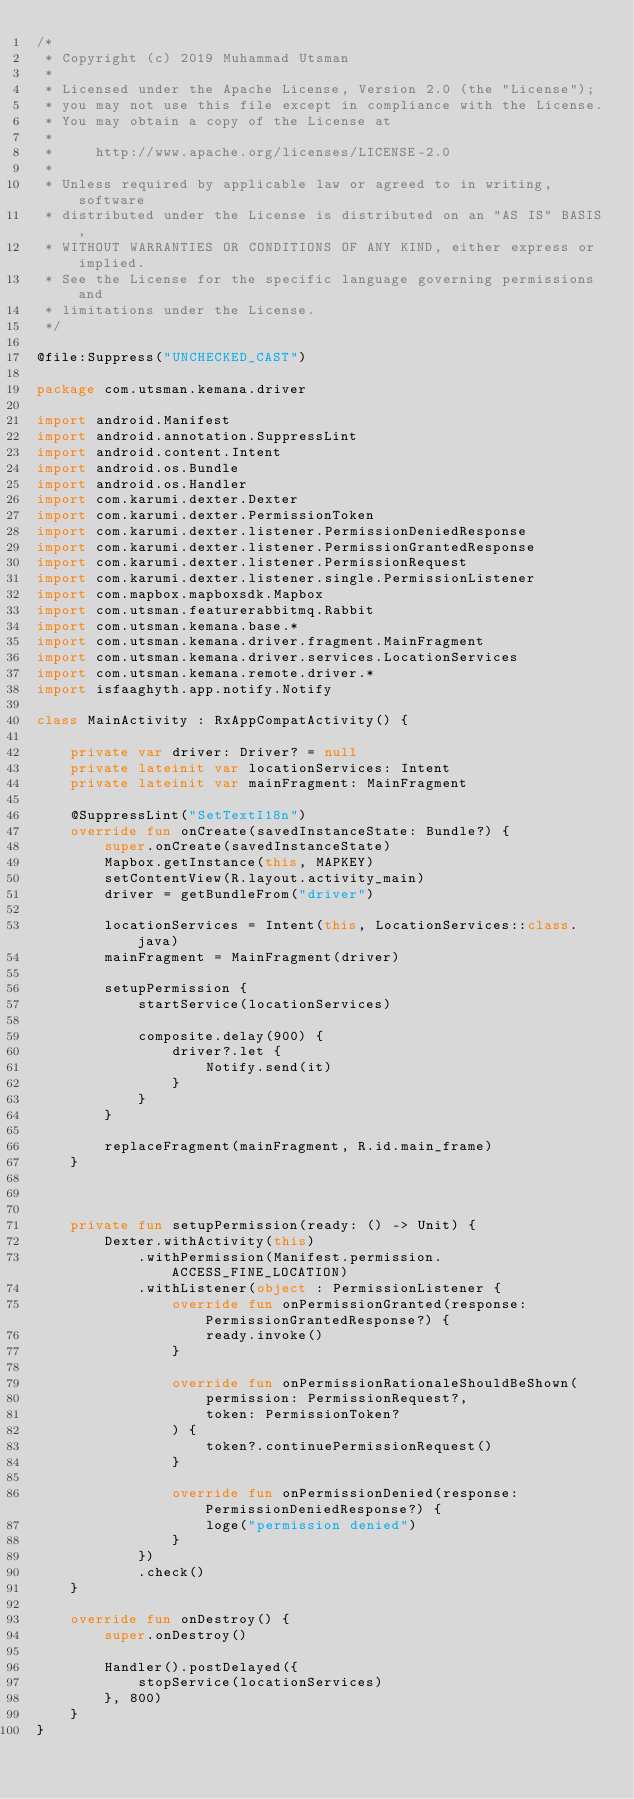<code> <loc_0><loc_0><loc_500><loc_500><_Kotlin_>/*
 * Copyright (c) 2019 Muhammad Utsman
 *
 * Licensed under the Apache License, Version 2.0 (the "License");
 * you may not use this file except in compliance with the License.
 * You may obtain a copy of the License at
 *
 *     http://www.apache.org/licenses/LICENSE-2.0
 *
 * Unless required by applicable law or agreed to in writing, software
 * distributed under the License is distributed on an "AS IS" BASIS,
 * WITHOUT WARRANTIES OR CONDITIONS OF ANY KIND, either express or implied.
 * See the License for the specific language governing permissions and
 * limitations under the License.
 */

@file:Suppress("UNCHECKED_CAST")

package com.utsman.kemana.driver

import android.Manifest
import android.annotation.SuppressLint
import android.content.Intent
import android.os.Bundle
import android.os.Handler
import com.karumi.dexter.Dexter
import com.karumi.dexter.PermissionToken
import com.karumi.dexter.listener.PermissionDeniedResponse
import com.karumi.dexter.listener.PermissionGrantedResponse
import com.karumi.dexter.listener.PermissionRequest
import com.karumi.dexter.listener.single.PermissionListener
import com.mapbox.mapboxsdk.Mapbox
import com.utsman.featurerabbitmq.Rabbit
import com.utsman.kemana.base.*
import com.utsman.kemana.driver.fragment.MainFragment
import com.utsman.kemana.driver.services.LocationServices
import com.utsman.kemana.remote.driver.*
import isfaaghyth.app.notify.Notify

class MainActivity : RxAppCompatActivity() {

    private var driver: Driver? = null
    private lateinit var locationServices: Intent
    private lateinit var mainFragment: MainFragment

    @SuppressLint("SetTextI18n")
    override fun onCreate(savedInstanceState: Bundle?) {
        super.onCreate(savedInstanceState)
        Mapbox.getInstance(this, MAPKEY)
        setContentView(R.layout.activity_main)
        driver = getBundleFrom("driver")

        locationServices = Intent(this, LocationServices::class.java)
        mainFragment = MainFragment(driver)

        setupPermission {
            startService(locationServices)

            composite.delay(900) {
                driver?.let {
                    Notify.send(it)
                }
            }
        }

        replaceFragment(mainFragment, R.id.main_frame)
    }



    private fun setupPermission(ready: () -> Unit) {
        Dexter.withActivity(this)
            .withPermission(Manifest.permission.ACCESS_FINE_LOCATION)
            .withListener(object : PermissionListener {
                override fun onPermissionGranted(response: PermissionGrantedResponse?) {
                    ready.invoke()
                }

                override fun onPermissionRationaleShouldBeShown(
                    permission: PermissionRequest?,
                    token: PermissionToken?
                ) {
                    token?.continuePermissionRequest()
                }

                override fun onPermissionDenied(response: PermissionDeniedResponse?) {
                    loge("permission denied")
                }
            })
            .check()
    }

    override fun onDestroy() {
        super.onDestroy()

        Handler().postDelayed({
            stopService(locationServices)
        }, 800)
    }
}</code> 